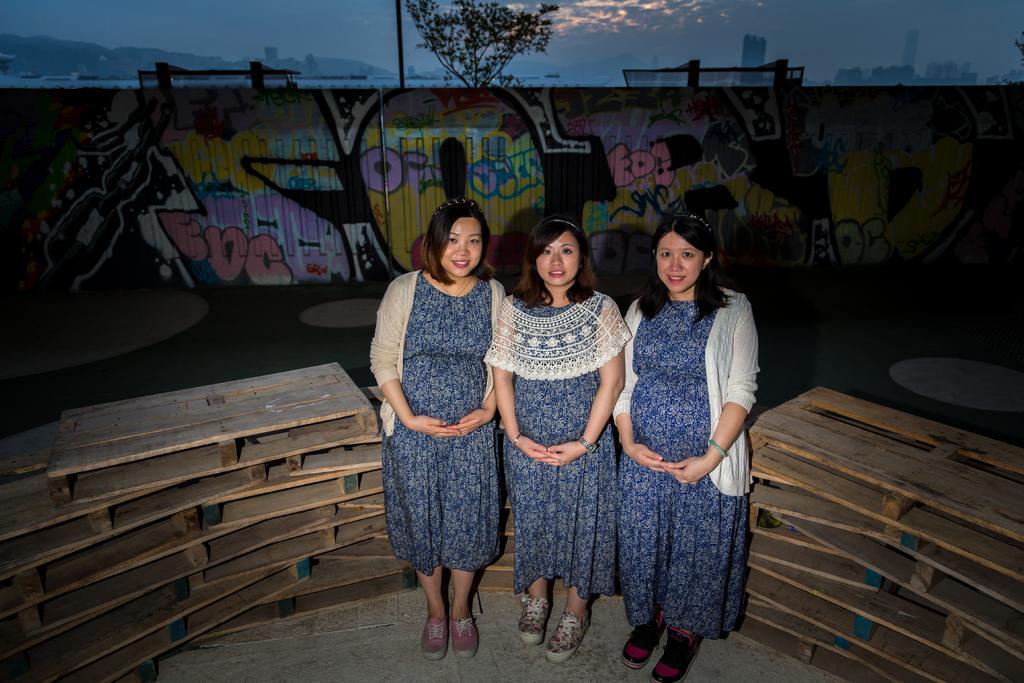Please provide a concise description of this image. In this image we can see women standing on the floor. In the background we can see wooden planks placed in the rows, wall with paintings, trees, hills, buildings and sky with clouds. 